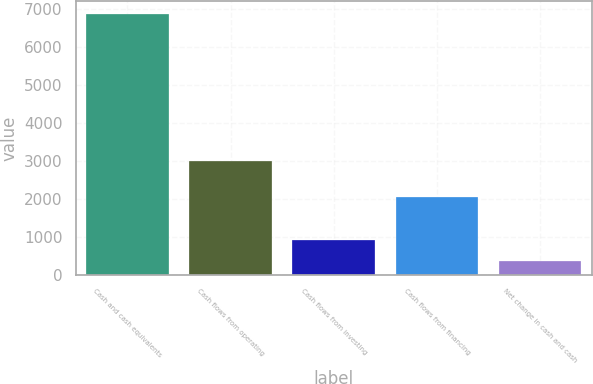Convert chart to OTSL. <chart><loc_0><loc_0><loc_500><loc_500><bar_chart><fcel>Cash and cash equivalents<fcel>Cash flows from operating<fcel>Cash flows from investing<fcel>Cash flows from financing<fcel>Net change in cash and cash<nl><fcel>6869.2<fcel>3004<fcel>933.1<fcel>2064<fcel>360<nl></chart> 